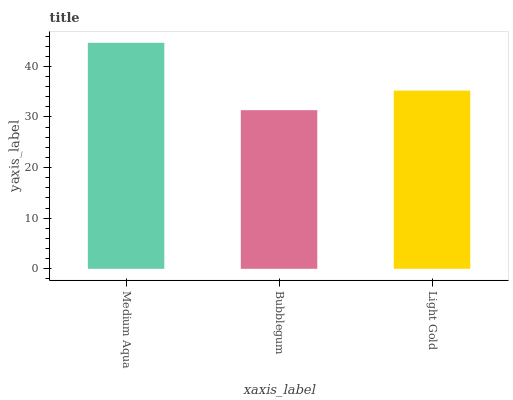Is Light Gold the minimum?
Answer yes or no. No. Is Light Gold the maximum?
Answer yes or no. No. Is Light Gold greater than Bubblegum?
Answer yes or no. Yes. Is Bubblegum less than Light Gold?
Answer yes or no. Yes. Is Bubblegum greater than Light Gold?
Answer yes or no. No. Is Light Gold less than Bubblegum?
Answer yes or no. No. Is Light Gold the high median?
Answer yes or no. Yes. Is Light Gold the low median?
Answer yes or no. Yes. Is Bubblegum the high median?
Answer yes or no. No. Is Medium Aqua the low median?
Answer yes or no. No. 